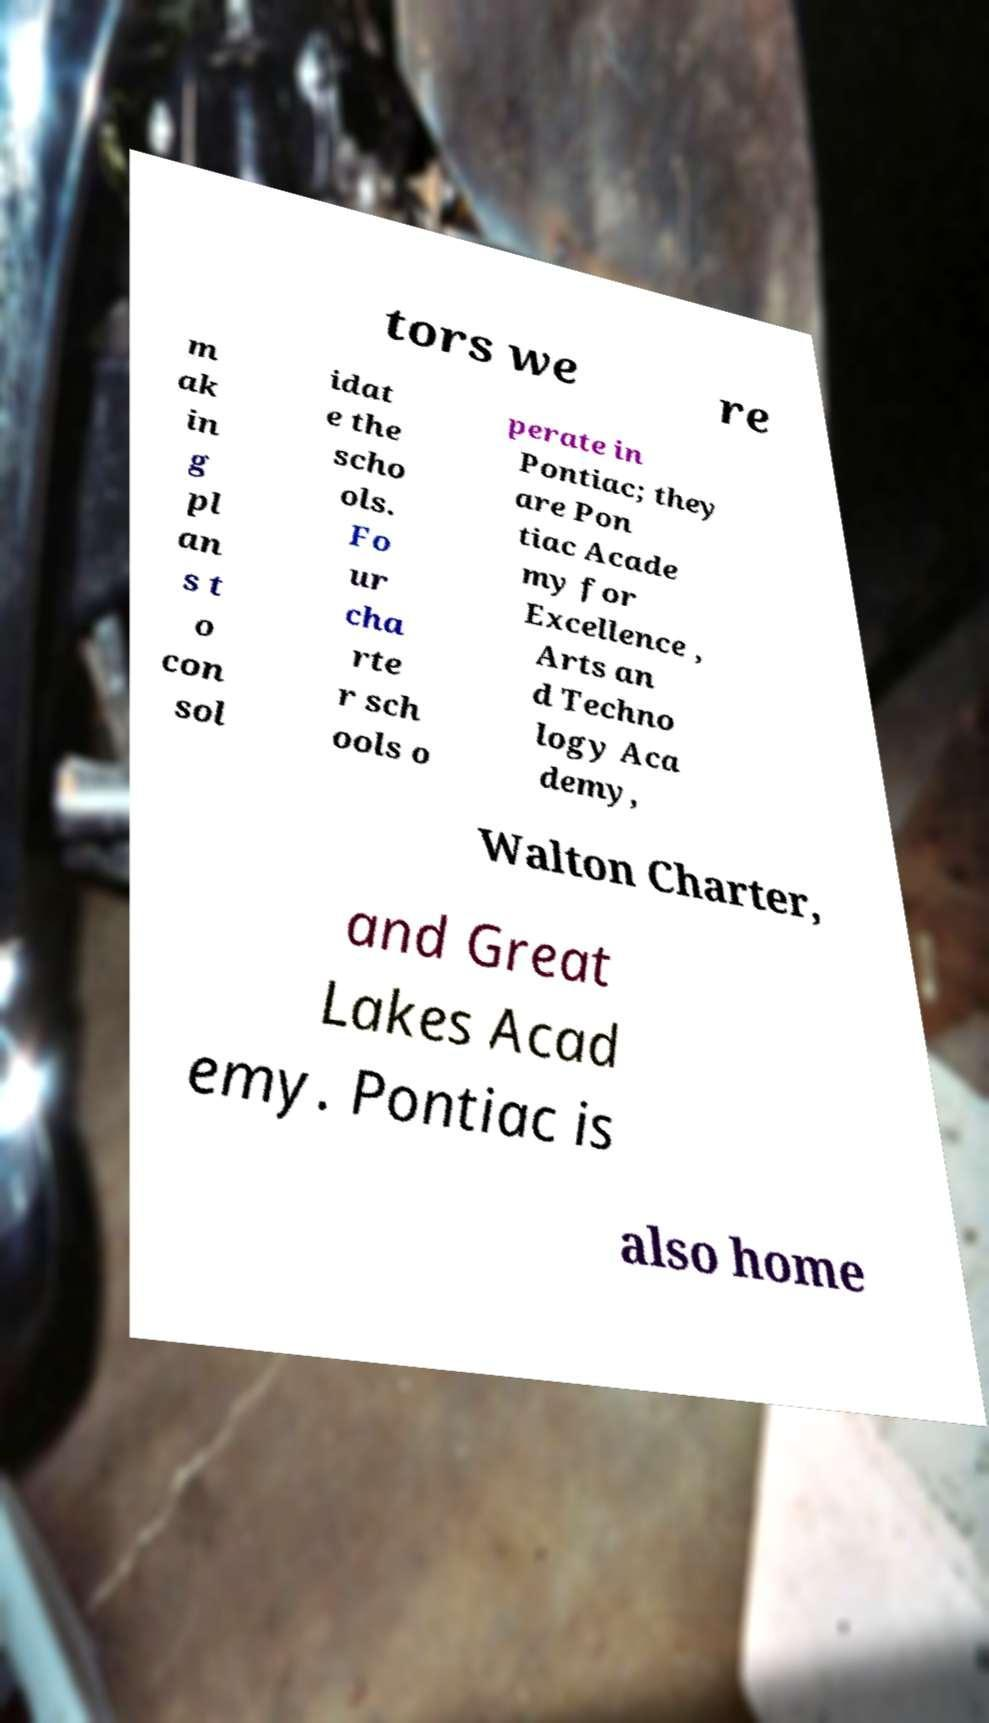Can you accurately transcribe the text from the provided image for me? tors we re m ak in g pl an s t o con sol idat e the scho ols. Fo ur cha rte r sch ools o perate in Pontiac; they are Pon tiac Acade my for Excellence , Arts an d Techno logy Aca demy, Walton Charter, and Great Lakes Acad emy. Pontiac is also home 